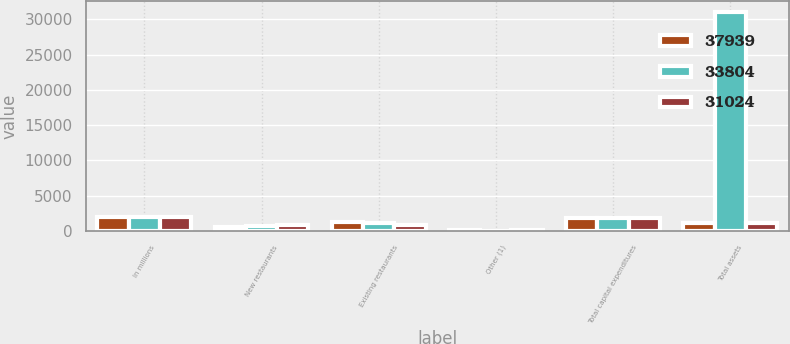Convert chart to OTSL. <chart><loc_0><loc_0><loc_500><loc_500><stacked_bar_chart><ecel><fcel>In millions<fcel>New restaurants<fcel>Existing restaurants<fcel>Other (1)<fcel>Total capital expenditures<fcel>Total assets<nl><fcel>37939<fcel>2017<fcel>537<fcel>1236<fcel>81<fcel>1854<fcel>1172<nl><fcel>33804<fcel>2016<fcel>674<fcel>1108<fcel>39<fcel>1821<fcel>31024<nl><fcel>31024<fcel>2015<fcel>892<fcel>842<fcel>80<fcel>1814<fcel>1172<nl></chart> 